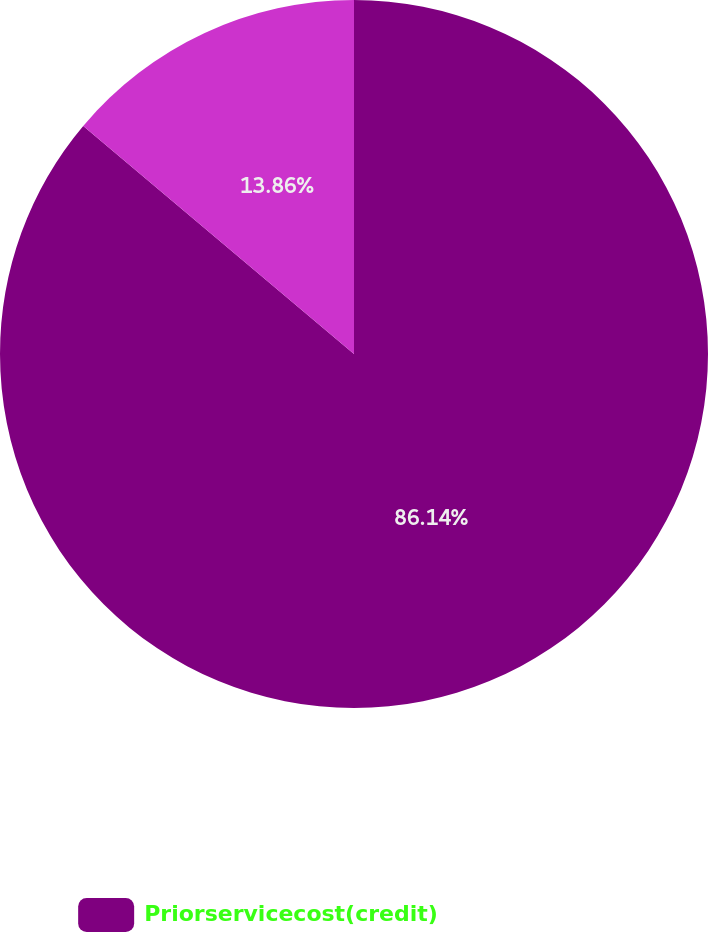<chart> <loc_0><loc_0><loc_500><loc_500><pie_chart><fcel>Priorservicecost(credit)<fcel>Unnamed: 1<nl><fcel>86.14%<fcel>13.86%<nl></chart> 